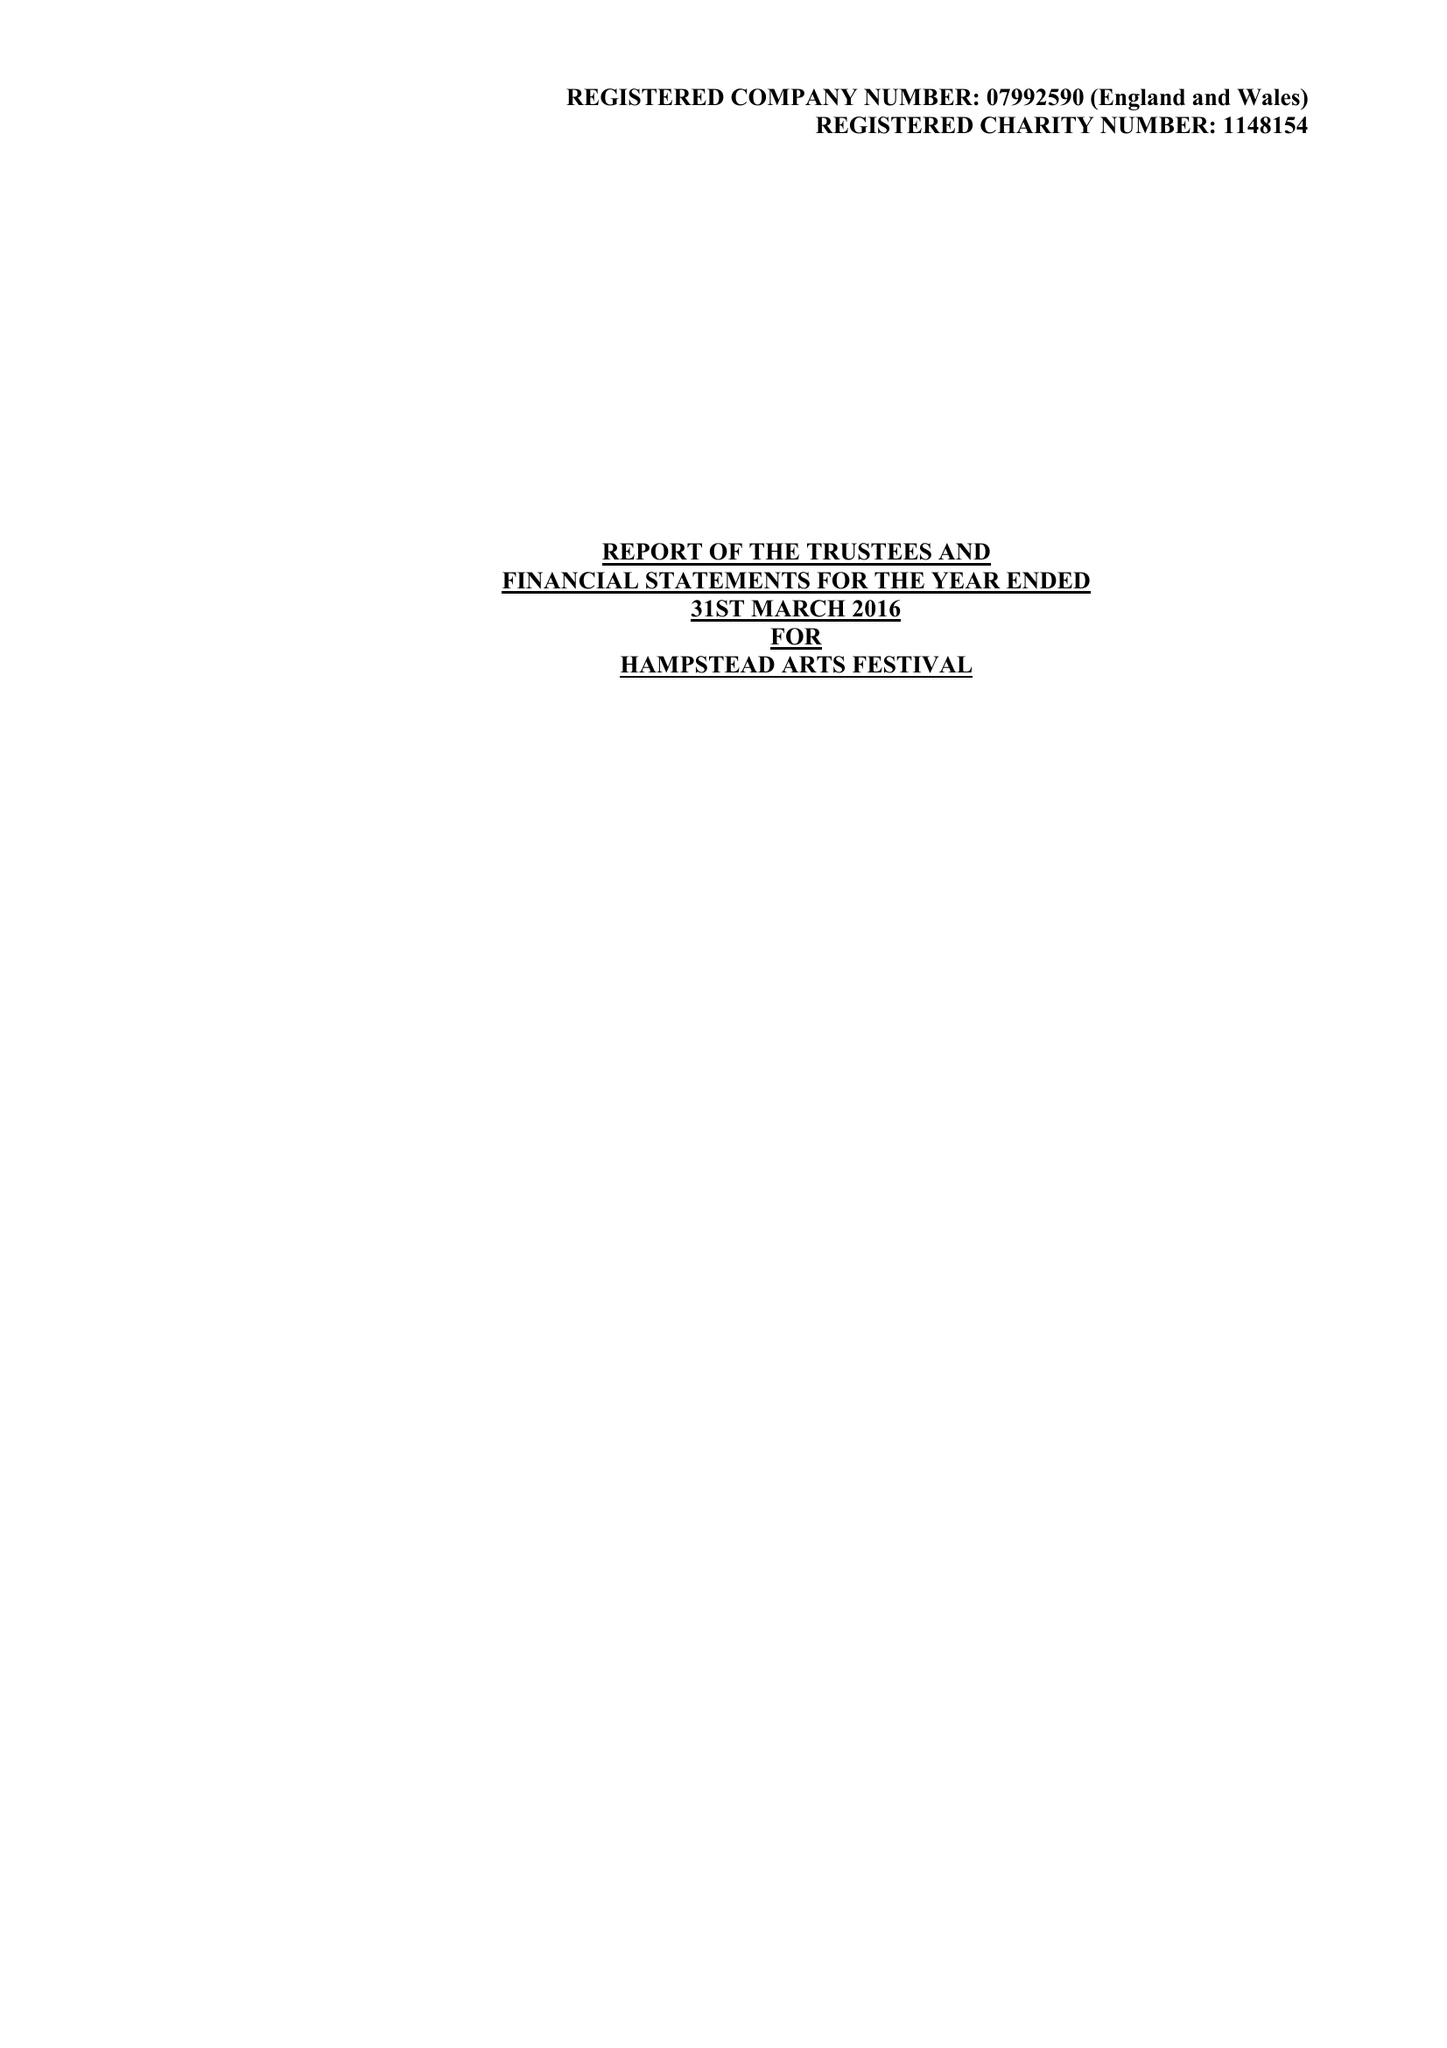What is the value for the report_date?
Answer the question using a single word or phrase. 2016-03-31 